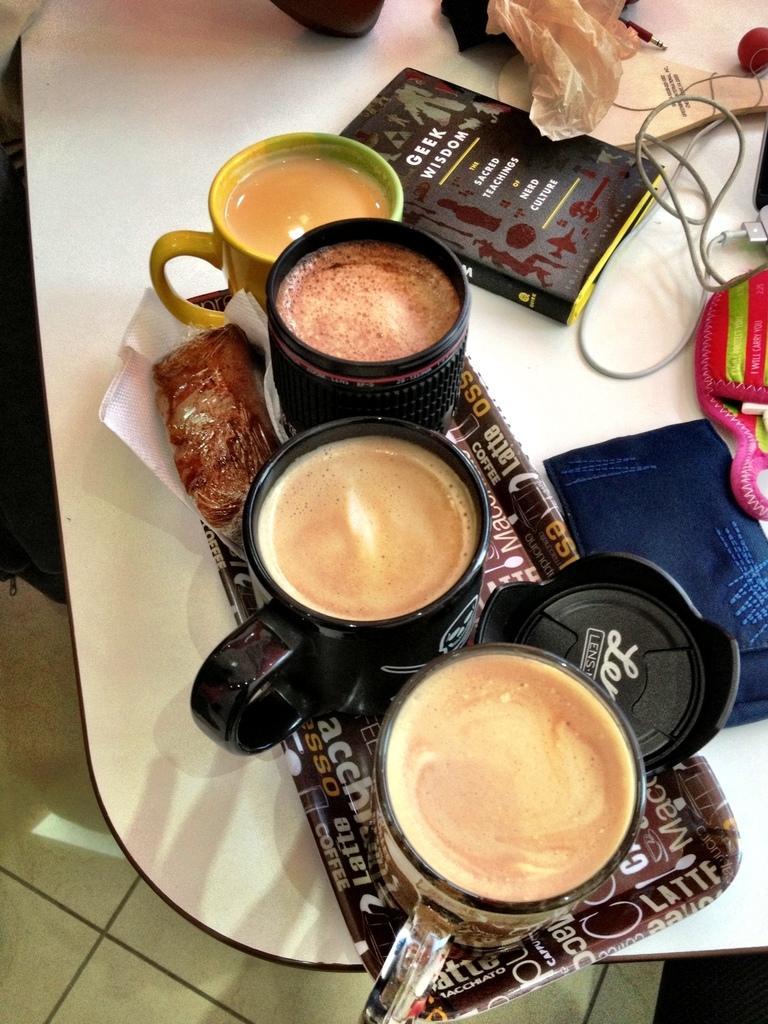Can you describe this image briefly? In the foreground of this image, on the tray, there are four cups, a crap, tissues and a food item on the table. The table also includes a book, cable, cover, wooden bat, ball and two pouches like an objects. In the background, there is the floor. 